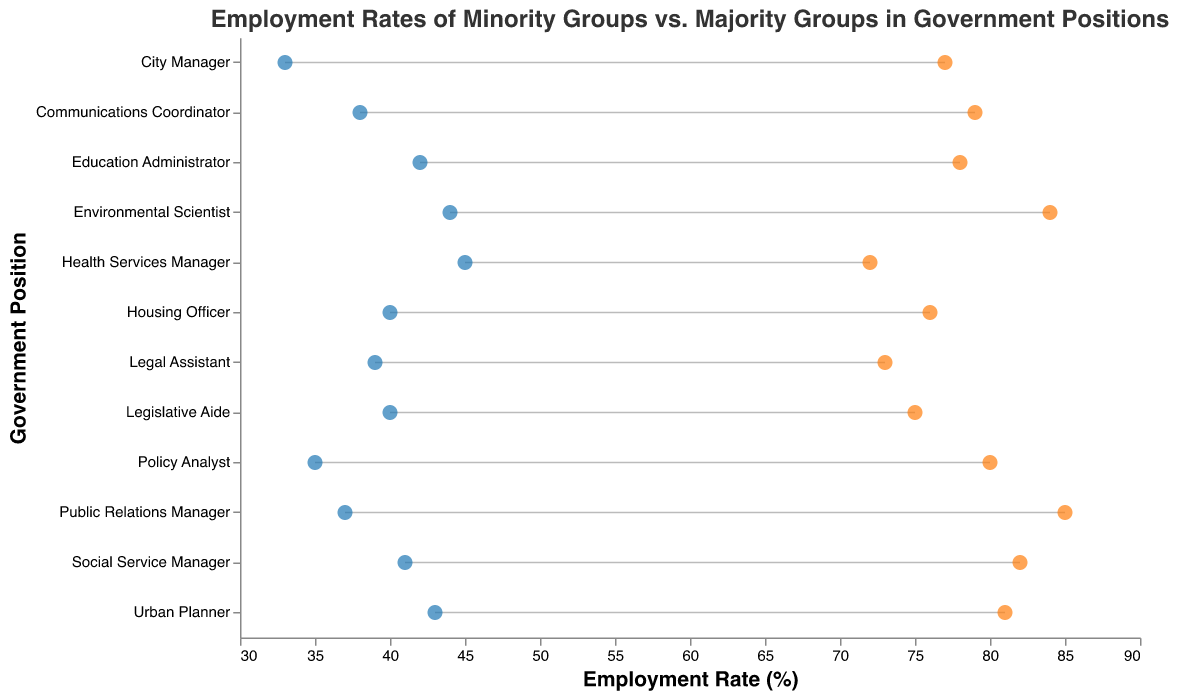How many government positions are displayed in the graph? Each rule on the y-axis represents a government position. Count the number of distinct positions listed on the y-axis. There are 12 positions displayed.
Answer: 12 Between which two roles is the employment gap between majority and minority groups the smallest? Calculate the difference in employment rates between the majority and minority groups for all roles. Find the one with the smallest difference. The smallest gap is in the role of Urban Planner with a difference of 81% - 43% = 38%.
Answer: Urban Planner What is the minority employment rate for Policy Analyst among Hispanics? Locate the Policy Analyst position and check the Minority Employment Rate for the Hispanic group, which is represented by a blue dot. The Minority Employment Rate is 35%.
Answer: 35% On average, how many percentage points lower are the minority employment rates compared to their majority counterparts across all positions? Calculate the difference for each position: 75-40, 80-35, 78-42, 85-37, 72-45, 81-43, 73-39, 77-33, 84-44, 82-41, 79-38, 76-40, then find the average of these differences: (35+45+36+48+27+38+34+44+40+41+41+36)/12 = 38.25.
Answer: 38.25 Which government position shows the highest majority employment rate? Check all the positions and find the one with the highest value for Majority Employment Rate, indicated by the orange dot at 85%. The role is Public Relations Manager.
Answer: Public Relations Manager In which position is the minority representation highest, and what is the corresponding employment rate? Locate the position with the highest Minority Employment Rate, indicated by a blue dot at 45%. The role is Health Services Manager.
Answer: Health Services Manager, 45% 